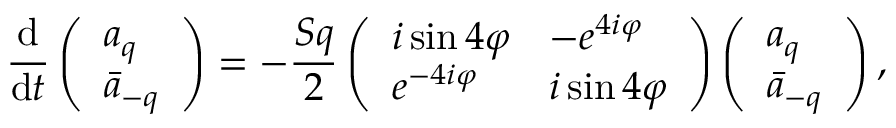<formula> <loc_0><loc_0><loc_500><loc_500>\frac { d } { d t } \left ( \begin{array} { l } { a _ { q } } \\ { \ B a r { a } _ { - q } } \end{array} \right ) = - \frac { S q } { 2 } \left ( \begin{array} { l l } { i \sin { 4 \varphi } } & { - e ^ { 4 i \varphi } } \\ { e ^ { - 4 i \varphi } } & { i \sin { 4 \varphi } } \end{array} \right ) \left ( \begin{array} { l } { a _ { q } } \\ { \ B a r { a } _ { - q } } \end{array} \right ) ,</formula> 